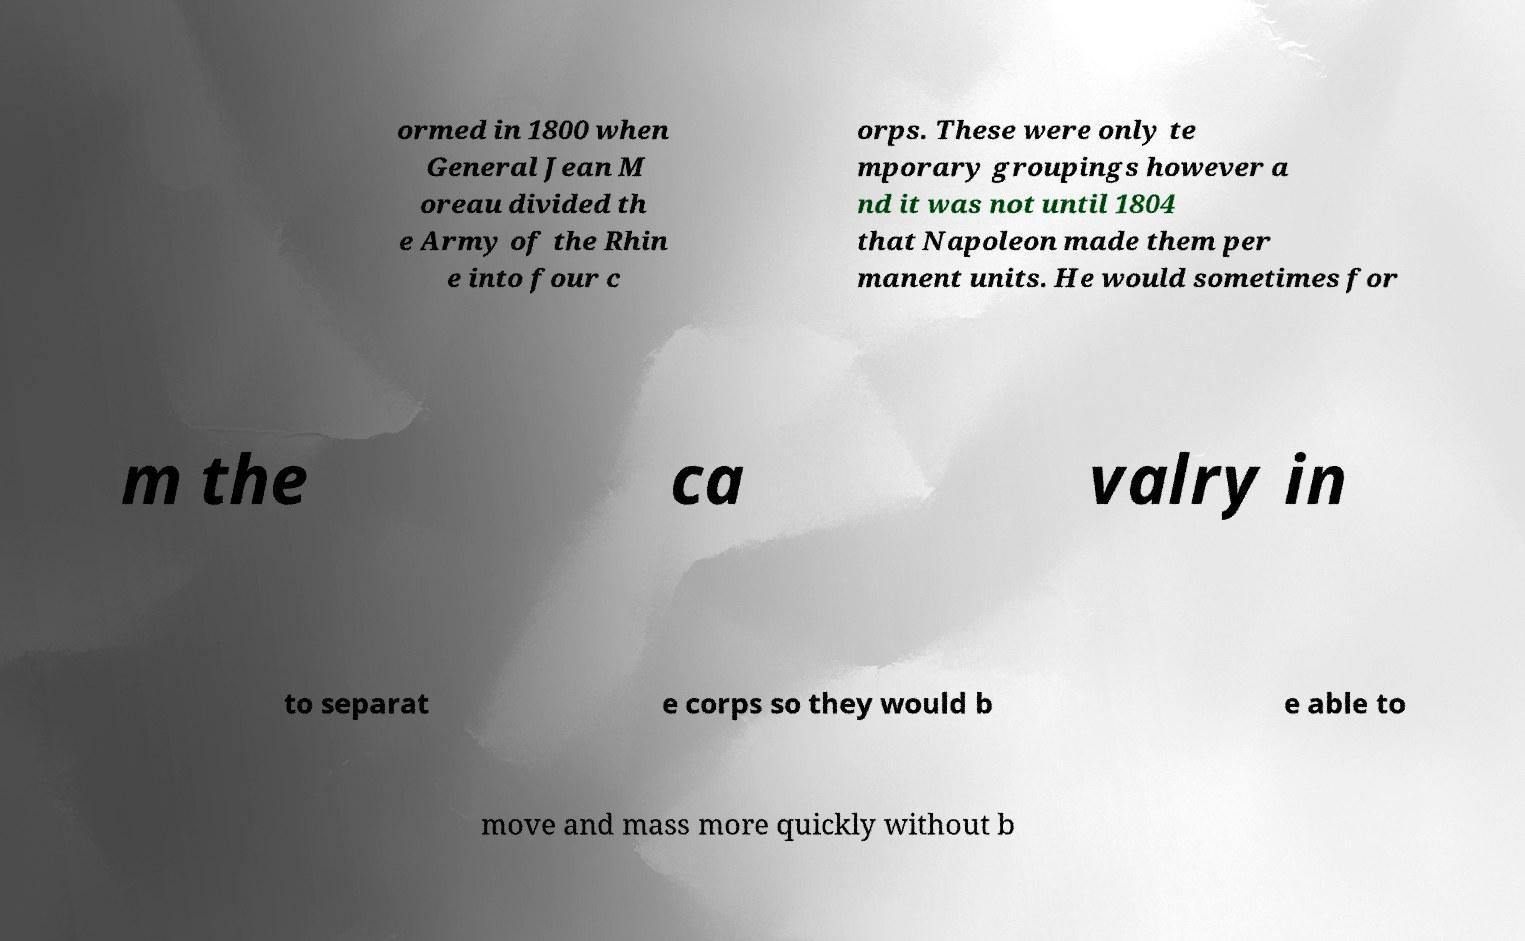Can you read and provide the text displayed in the image?This photo seems to have some interesting text. Can you extract and type it out for me? ormed in 1800 when General Jean M oreau divided th e Army of the Rhin e into four c orps. These were only te mporary groupings however a nd it was not until 1804 that Napoleon made them per manent units. He would sometimes for m the ca valry in to separat e corps so they would b e able to move and mass more quickly without b 